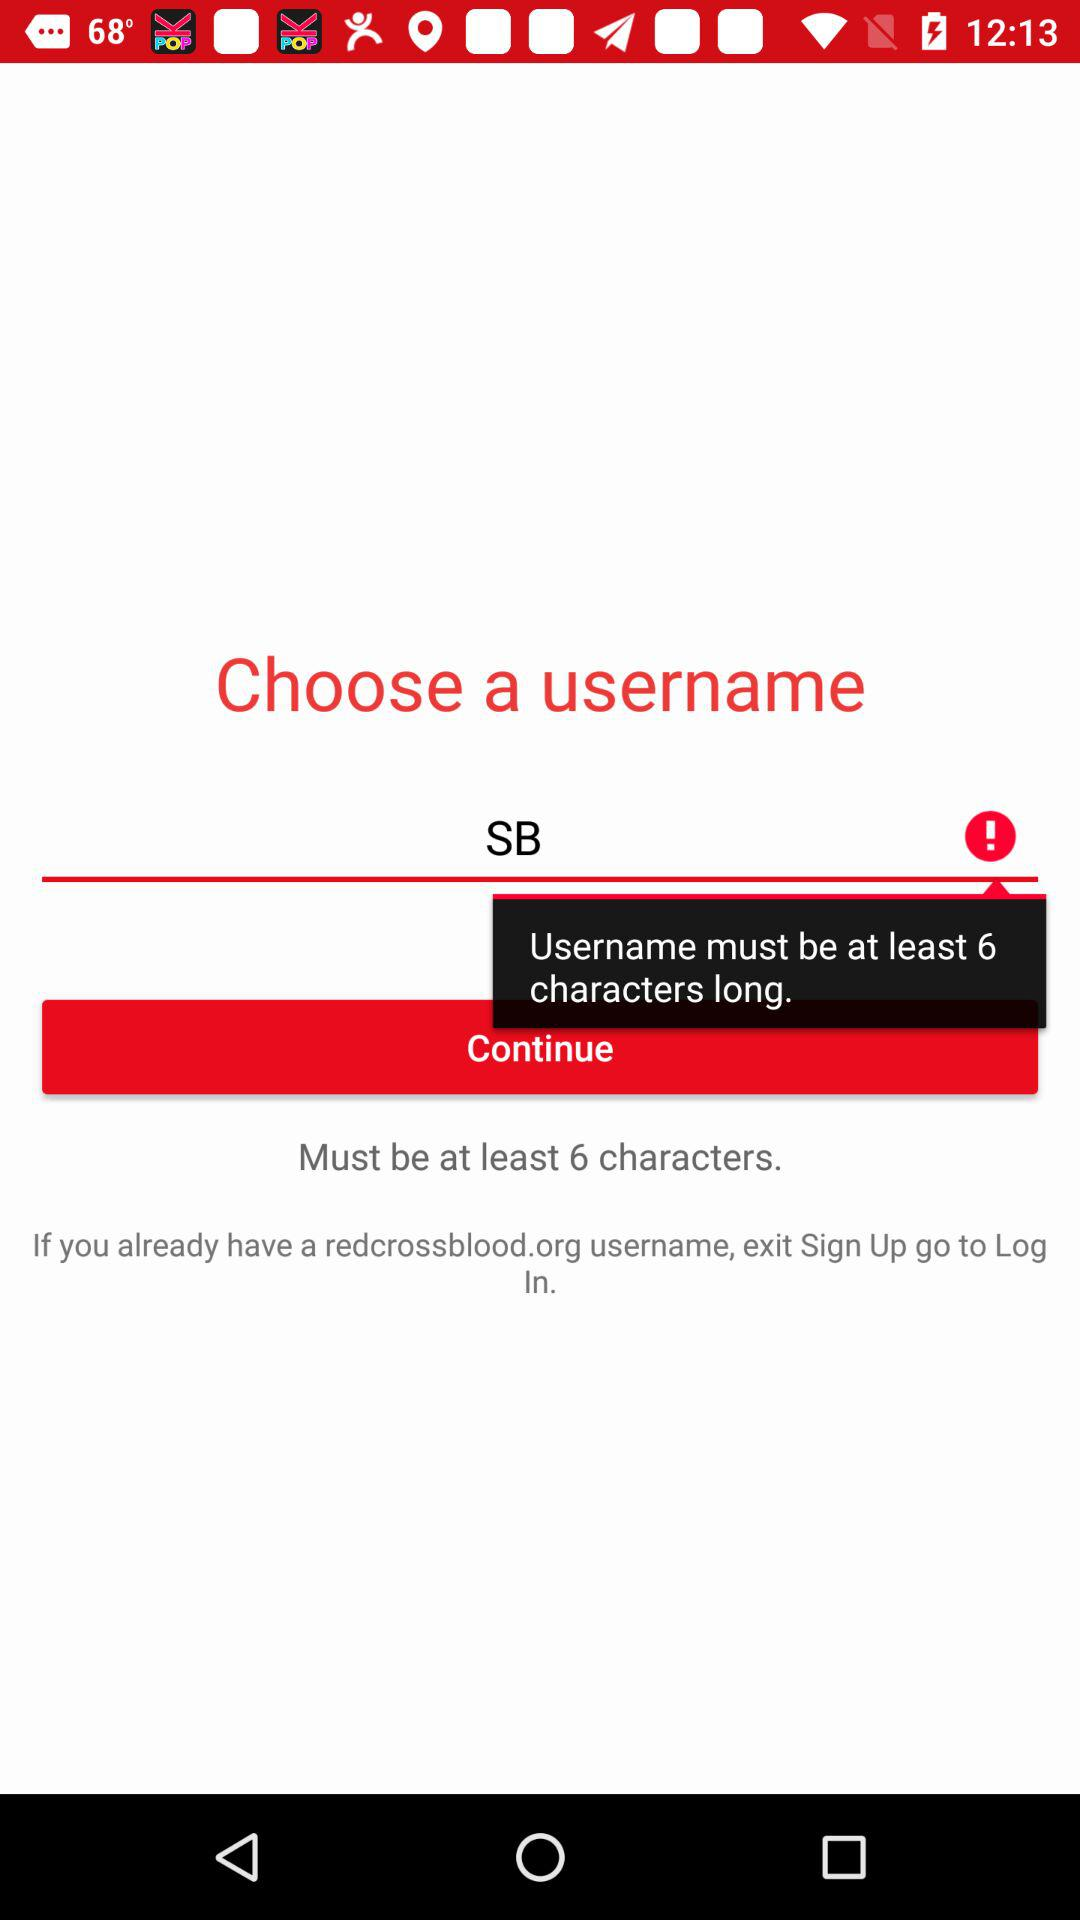How many minimum characters should a username have? The username must have a minimum of 6 characters. 